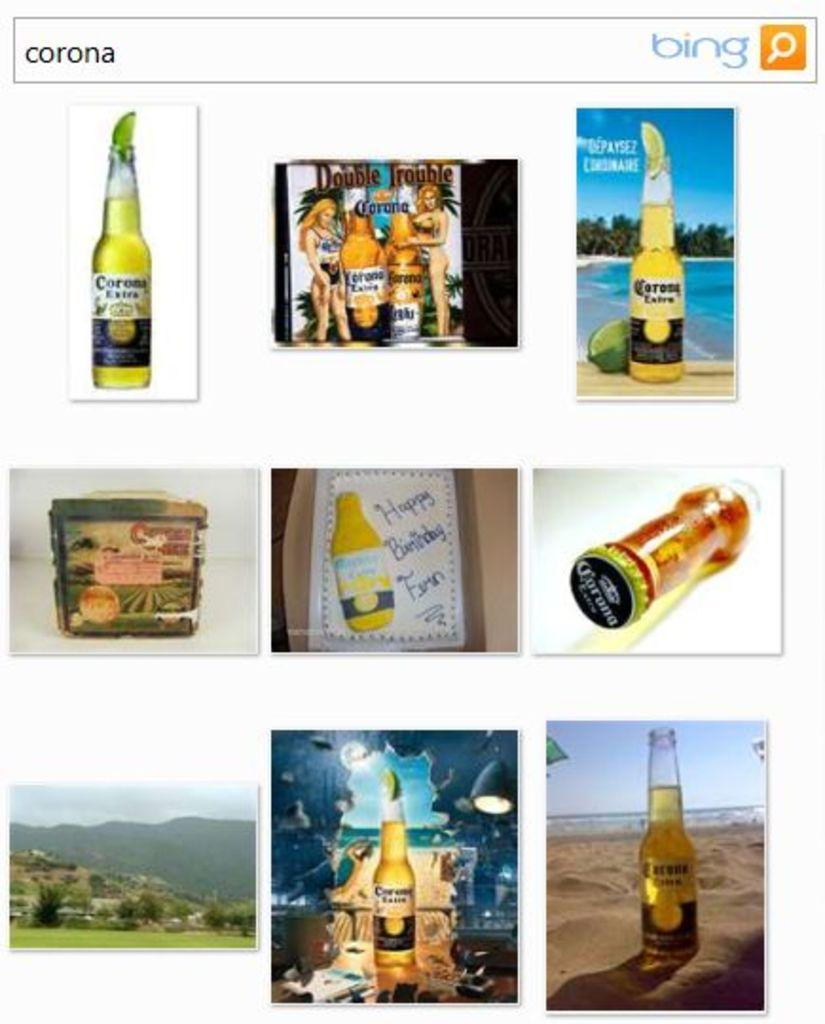<image>
Relay a brief, clear account of the picture shown. bing search results for corona with a bottle and cake 